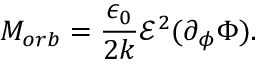Convert formula to latex. <formula><loc_0><loc_0><loc_500><loc_500>M _ { o r b } = \frac { \epsilon _ { 0 } } { 2 k } \mathcal { E } ^ { 2 } ( \partial _ { \phi } \Phi ) .</formula> 